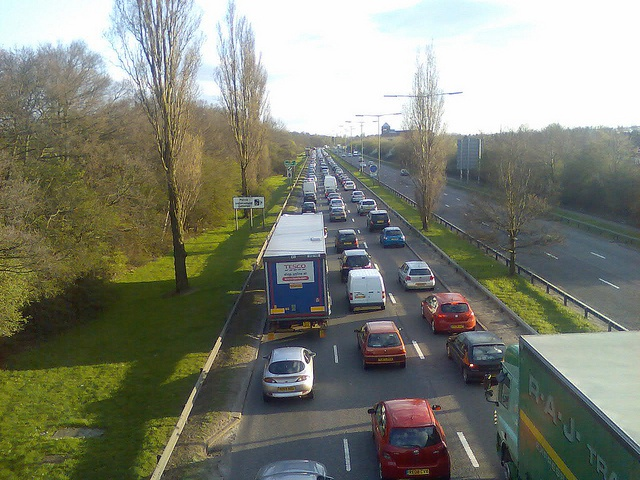Describe the objects in this image and their specific colors. I can see car in lightblue, gray, black, darkgreen, and lightgray tones, truck in lightblue, darkgreen, black, lightgray, and gray tones, truck in lightblue, navy, lightgray, gray, and black tones, car in lightblue, black, maroon, brown, and gray tones, and car in lightblue, gray, darkgray, white, and navy tones in this image. 